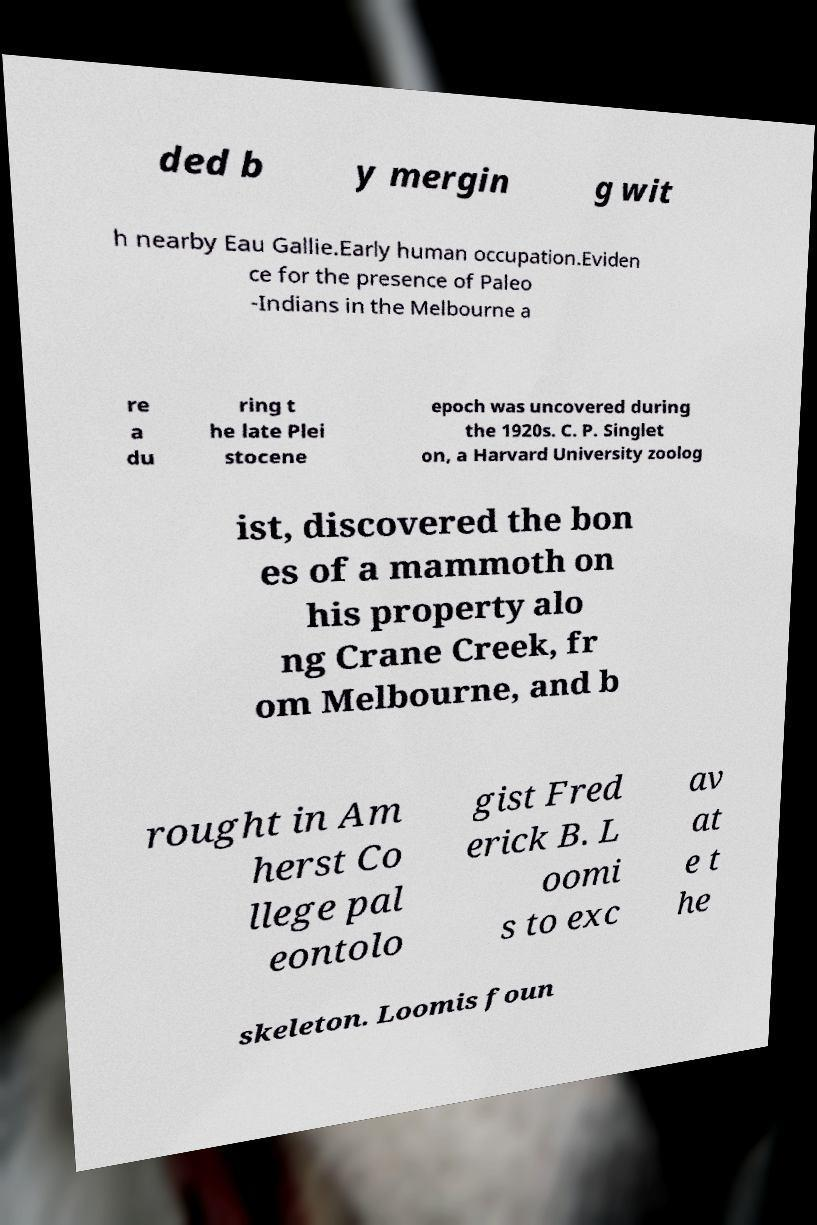Can you read and provide the text displayed in the image?This photo seems to have some interesting text. Can you extract and type it out for me? ded b y mergin g wit h nearby Eau Gallie.Early human occupation.Eviden ce for the presence of Paleo -Indians in the Melbourne a re a du ring t he late Plei stocene epoch was uncovered during the 1920s. C. P. Singlet on, a Harvard University zoolog ist, discovered the bon es of a mammoth on his property alo ng Crane Creek, fr om Melbourne, and b rought in Am herst Co llege pal eontolo gist Fred erick B. L oomi s to exc av at e t he skeleton. Loomis foun 